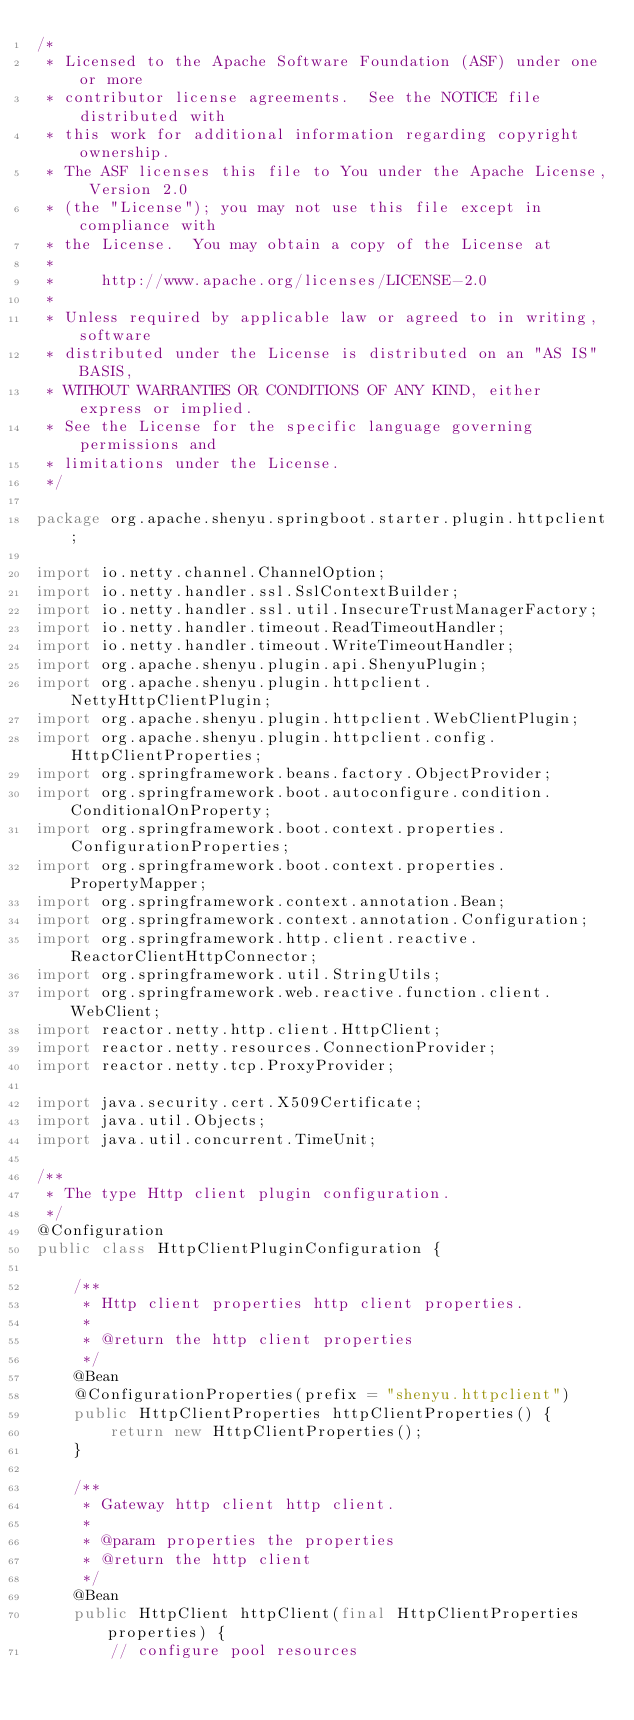<code> <loc_0><loc_0><loc_500><loc_500><_Java_>/*
 * Licensed to the Apache Software Foundation (ASF) under one or more
 * contributor license agreements.  See the NOTICE file distributed with
 * this work for additional information regarding copyright ownership.
 * The ASF licenses this file to You under the Apache License, Version 2.0
 * (the "License"); you may not use this file except in compliance with
 * the License.  You may obtain a copy of the License at
 *
 *     http://www.apache.org/licenses/LICENSE-2.0
 *
 * Unless required by applicable law or agreed to in writing, software
 * distributed under the License is distributed on an "AS IS" BASIS,
 * WITHOUT WARRANTIES OR CONDITIONS OF ANY KIND, either express or implied.
 * See the License for the specific language governing permissions and
 * limitations under the License.
 */

package org.apache.shenyu.springboot.starter.plugin.httpclient;

import io.netty.channel.ChannelOption;
import io.netty.handler.ssl.SslContextBuilder;
import io.netty.handler.ssl.util.InsecureTrustManagerFactory;
import io.netty.handler.timeout.ReadTimeoutHandler;
import io.netty.handler.timeout.WriteTimeoutHandler;
import org.apache.shenyu.plugin.api.ShenyuPlugin;
import org.apache.shenyu.plugin.httpclient.NettyHttpClientPlugin;
import org.apache.shenyu.plugin.httpclient.WebClientPlugin;
import org.apache.shenyu.plugin.httpclient.config.HttpClientProperties;
import org.springframework.beans.factory.ObjectProvider;
import org.springframework.boot.autoconfigure.condition.ConditionalOnProperty;
import org.springframework.boot.context.properties.ConfigurationProperties;
import org.springframework.boot.context.properties.PropertyMapper;
import org.springframework.context.annotation.Bean;
import org.springframework.context.annotation.Configuration;
import org.springframework.http.client.reactive.ReactorClientHttpConnector;
import org.springframework.util.StringUtils;
import org.springframework.web.reactive.function.client.WebClient;
import reactor.netty.http.client.HttpClient;
import reactor.netty.resources.ConnectionProvider;
import reactor.netty.tcp.ProxyProvider;

import java.security.cert.X509Certificate;
import java.util.Objects;
import java.util.concurrent.TimeUnit;

/**
 * The type Http client plugin configuration.
 */
@Configuration
public class HttpClientPluginConfiguration {

    /**
     * Http client properties http client properties.
     *
     * @return the http client properties
     */
    @Bean
    @ConfigurationProperties(prefix = "shenyu.httpclient")
    public HttpClientProperties httpClientProperties() {
        return new HttpClientProperties();
    }

    /**
     * Gateway http client http client.
     *
     * @param properties the properties
     * @return the http client
     */
    @Bean
    public HttpClient httpClient(final HttpClientProperties properties) {
        // configure pool resources</code> 